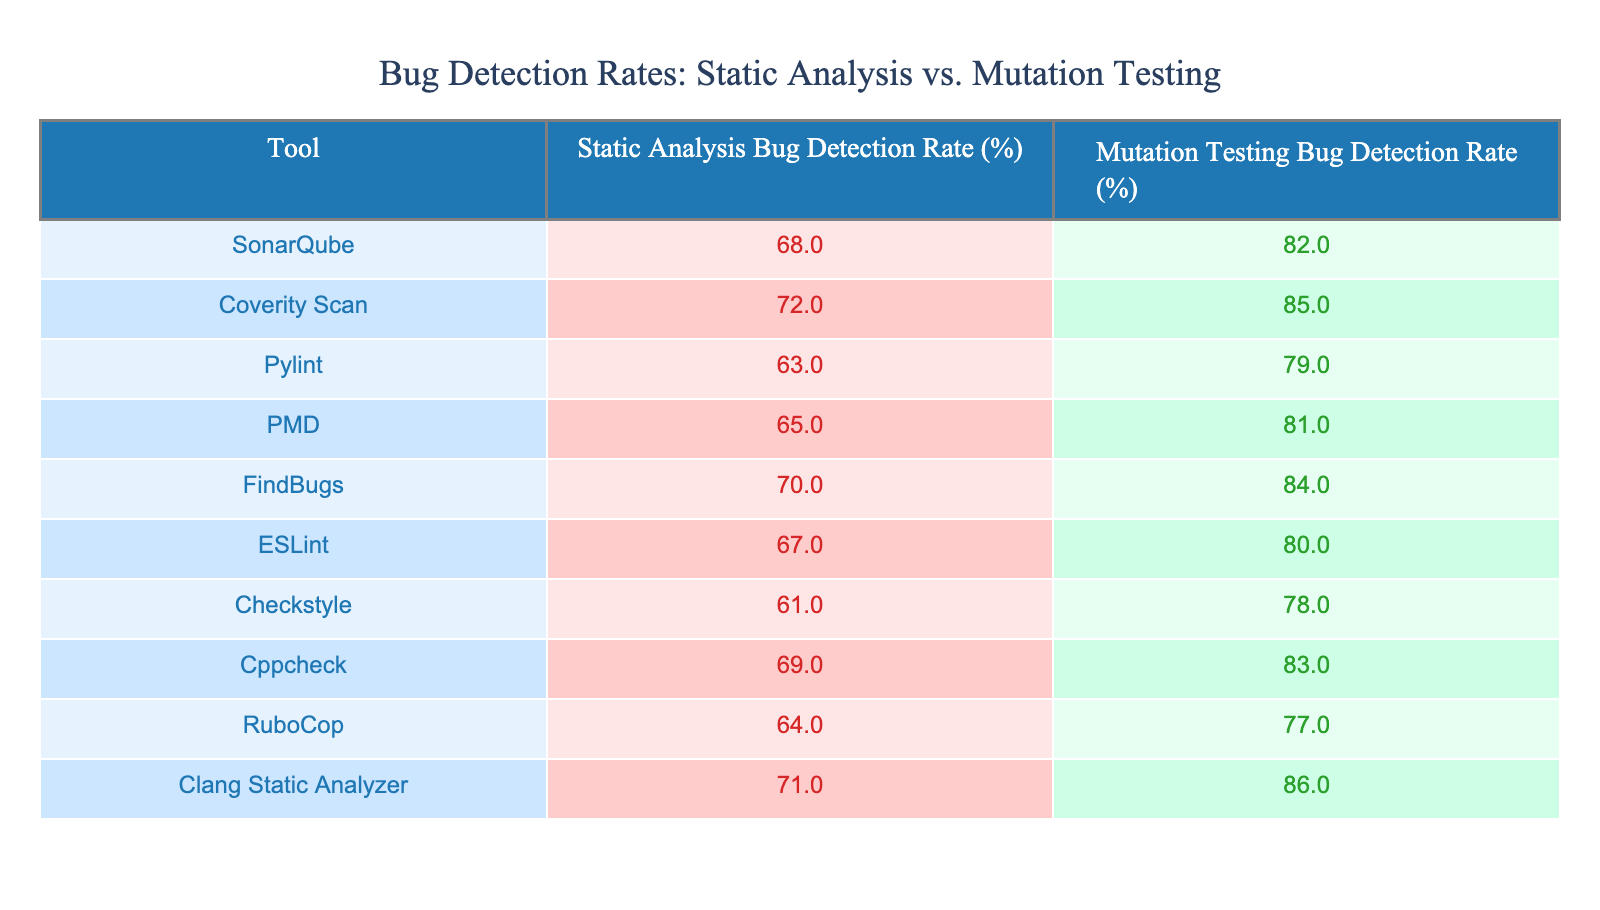What is the bug detection rate of SonarQube for static analysis? From the table, I can find SonarQube in the first row under the "Static Analysis Bug Detection Rate (%)" column, which shows a value of 68%.
Answer: 68% Which tool has the highest bug detection rate for mutation testing? Looking at the "Mutation Testing Bug Detection Rate (%)" column, I see that Clang Static Analyzer has the highest value of 86%, which is greater than all other tools listed.
Answer: 86% What is the difference in bug detection rates between FindBugs and Pylint for static analysis? I need to find the values for FindBugs and Pylint under the "Static Analysis Bug Detection Rate (%)" column. FindBugs has a rate of 70% and Pylint has a rate of 63%. The difference is 70 - 63 = 7.
Answer: 7% Is the bug detection rate for static analysis higher than that for mutation testing for any tool? I compare the static analysis and mutation testing rates for all tools. SonarQube (68% vs 82%), Coverity Scan (72% vs 85%), Pylint (63% vs 79%), PMD (65% vs 81%), FindBugs (70% vs 84%), ESLint (67% vs 80%), Checkstyle (61% vs 78%), Cppcheck (69% vs 83%), RuboCop (64% vs 77%), and Clang Static Analyzer (71% vs 86%) show that for all tools, the static analysis rate is lower than the mutation testing rate.
Answer: No What is the average bug detection rate for static analysis across all tools? I will sum the static analysis rates: 68 + 72 + 63 + 65 + 70 + 67 + 61 + 69 + 64 + 71 =  690. There are 10 tools, so I divide the total by 10: 690 / 10 = 69.
Answer: 69 Which tool has the lowest bug detection rate for mutation testing, and what is that percentage? I check the "Mutation Testing Bug Detection Rate (%)" column and find RuboCop with the lowest rate of 77%, which is less than all other percentages listed.
Answer: 77% What is the combined bug detection rate of Clang Static Analyzer for both static analysis and mutation testing? Clang Static Analyzer has a static analysis rate of 71% and a mutation testing rate of 86%. Adding these together gives 71 + 86 = 157.
Answer: 157 Which static analysis tool has a bug detection rate closest to the average of all static analysis tools? The average static analysis rate is 69%. The static analysis rates are: SonarQube (68%), Coverity Scan (72%), Pylint (63%), PMD (65%), FindBugs (70%), ESLint (67%), Checkstyle (61%), Cppcheck (69%), RuboCop (64%), Clang Static Analyzer (71%). The rates closest to 69% are SonarQube (68%) and Cppcheck (69%), so either could be considered.
Answer: SonarQube or Cppcheck 